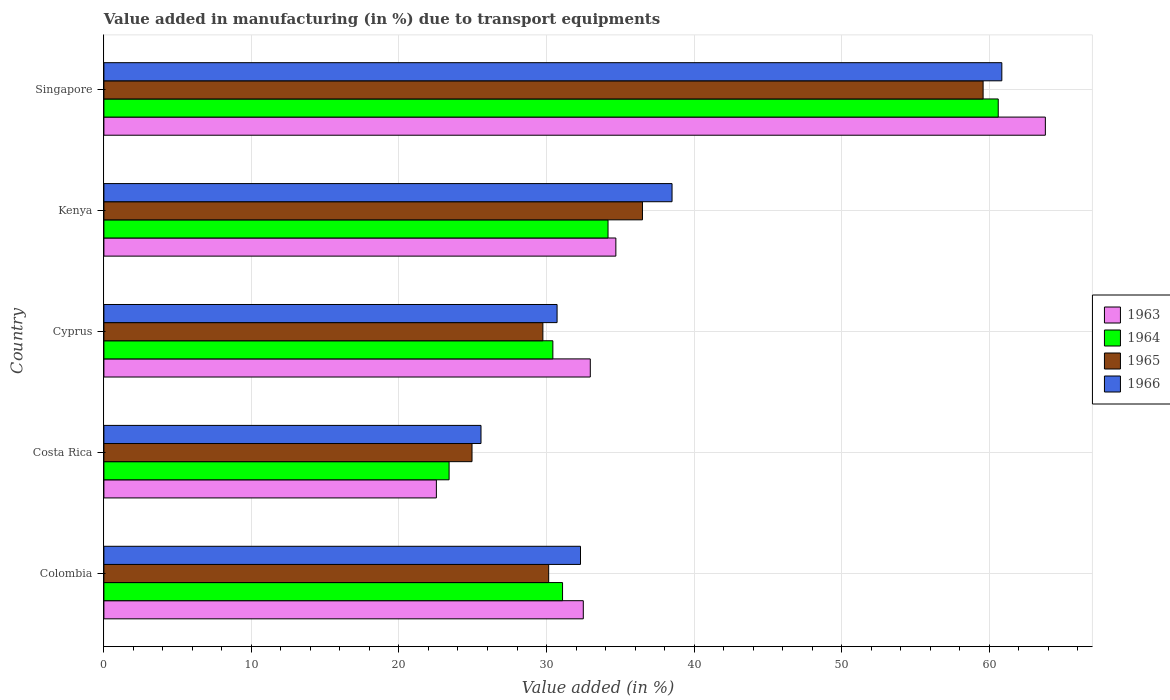How many different coloured bars are there?
Offer a terse response. 4. Are the number of bars per tick equal to the number of legend labels?
Your response must be concise. Yes. Are the number of bars on each tick of the Y-axis equal?
Offer a terse response. Yes. How many bars are there on the 2nd tick from the bottom?
Make the answer very short. 4. What is the label of the 4th group of bars from the top?
Make the answer very short. Costa Rica. In how many cases, is the number of bars for a given country not equal to the number of legend labels?
Your answer should be compact. 0. What is the percentage of value added in manufacturing due to transport equipments in 1963 in Cyprus?
Your response must be concise. 32.97. Across all countries, what is the maximum percentage of value added in manufacturing due to transport equipments in 1965?
Make the answer very short. 59.59. Across all countries, what is the minimum percentage of value added in manufacturing due to transport equipments in 1963?
Provide a short and direct response. 22.53. In which country was the percentage of value added in manufacturing due to transport equipments in 1965 maximum?
Provide a short and direct response. Singapore. What is the total percentage of value added in manufacturing due to transport equipments in 1964 in the graph?
Provide a succinct answer. 179.7. What is the difference between the percentage of value added in manufacturing due to transport equipments in 1963 in Colombia and that in Singapore?
Your response must be concise. -31.32. What is the difference between the percentage of value added in manufacturing due to transport equipments in 1963 in Cyprus and the percentage of value added in manufacturing due to transport equipments in 1964 in Costa Rica?
Your answer should be very brief. 9.57. What is the average percentage of value added in manufacturing due to transport equipments in 1965 per country?
Your answer should be compact. 36.19. What is the difference between the percentage of value added in manufacturing due to transport equipments in 1966 and percentage of value added in manufacturing due to transport equipments in 1965 in Costa Rica?
Offer a very short reply. 0.61. In how many countries, is the percentage of value added in manufacturing due to transport equipments in 1966 greater than 62 %?
Keep it short and to the point. 0. What is the ratio of the percentage of value added in manufacturing due to transport equipments in 1966 in Colombia to that in Kenya?
Your answer should be very brief. 0.84. What is the difference between the highest and the second highest percentage of value added in manufacturing due to transport equipments in 1966?
Keep it short and to the point. 22.35. What is the difference between the highest and the lowest percentage of value added in manufacturing due to transport equipments in 1965?
Make the answer very short. 34.64. Is the sum of the percentage of value added in manufacturing due to transport equipments in 1963 in Colombia and Costa Rica greater than the maximum percentage of value added in manufacturing due to transport equipments in 1964 across all countries?
Give a very brief answer. No. What does the 3rd bar from the top in Cyprus represents?
Give a very brief answer. 1964. What does the 1st bar from the bottom in Cyprus represents?
Your answer should be very brief. 1963. How many bars are there?
Your answer should be very brief. 20. What is the difference between two consecutive major ticks on the X-axis?
Give a very brief answer. 10. Does the graph contain any zero values?
Ensure brevity in your answer.  No. Does the graph contain grids?
Your response must be concise. Yes. What is the title of the graph?
Offer a very short reply. Value added in manufacturing (in %) due to transport equipments. Does "1979" appear as one of the legend labels in the graph?
Provide a short and direct response. No. What is the label or title of the X-axis?
Your answer should be very brief. Value added (in %). What is the label or title of the Y-axis?
Provide a succinct answer. Country. What is the Value added (in %) in 1963 in Colombia?
Keep it short and to the point. 32.49. What is the Value added (in %) of 1964 in Colombia?
Ensure brevity in your answer.  31.09. What is the Value added (in %) of 1965 in Colombia?
Ensure brevity in your answer.  30.15. What is the Value added (in %) of 1966 in Colombia?
Give a very brief answer. 32.3. What is the Value added (in %) of 1963 in Costa Rica?
Your answer should be very brief. 22.53. What is the Value added (in %) in 1964 in Costa Rica?
Keep it short and to the point. 23.4. What is the Value added (in %) in 1965 in Costa Rica?
Your answer should be very brief. 24.95. What is the Value added (in %) in 1966 in Costa Rica?
Your response must be concise. 25.56. What is the Value added (in %) in 1963 in Cyprus?
Keep it short and to the point. 32.97. What is the Value added (in %) of 1964 in Cyprus?
Ensure brevity in your answer.  30.43. What is the Value added (in %) of 1965 in Cyprus?
Provide a short and direct response. 29.75. What is the Value added (in %) of 1966 in Cyprus?
Your answer should be very brief. 30.72. What is the Value added (in %) of 1963 in Kenya?
Your answer should be compact. 34.7. What is the Value added (in %) of 1964 in Kenya?
Offer a very short reply. 34.17. What is the Value added (in %) of 1965 in Kenya?
Offer a terse response. 36.5. What is the Value added (in %) in 1966 in Kenya?
Offer a terse response. 38.51. What is the Value added (in %) in 1963 in Singapore?
Give a very brief answer. 63.81. What is the Value added (in %) in 1964 in Singapore?
Give a very brief answer. 60.62. What is the Value added (in %) of 1965 in Singapore?
Your response must be concise. 59.59. What is the Value added (in %) of 1966 in Singapore?
Provide a succinct answer. 60.86. Across all countries, what is the maximum Value added (in %) in 1963?
Give a very brief answer. 63.81. Across all countries, what is the maximum Value added (in %) of 1964?
Ensure brevity in your answer.  60.62. Across all countries, what is the maximum Value added (in %) in 1965?
Ensure brevity in your answer.  59.59. Across all countries, what is the maximum Value added (in %) of 1966?
Your response must be concise. 60.86. Across all countries, what is the minimum Value added (in %) in 1963?
Give a very brief answer. 22.53. Across all countries, what is the minimum Value added (in %) in 1964?
Your response must be concise. 23.4. Across all countries, what is the minimum Value added (in %) of 1965?
Ensure brevity in your answer.  24.95. Across all countries, what is the minimum Value added (in %) in 1966?
Ensure brevity in your answer.  25.56. What is the total Value added (in %) in 1963 in the graph?
Offer a very short reply. 186.5. What is the total Value added (in %) of 1964 in the graph?
Ensure brevity in your answer.  179.7. What is the total Value added (in %) in 1965 in the graph?
Give a very brief answer. 180.94. What is the total Value added (in %) of 1966 in the graph?
Make the answer very short. 187.95. What is the difference between the Value added (in %) in 1963 in Colombia and that in Costa Rica?
Your response must be concise. 9.96. What is the difference between the Value added (in %) of 1964 in Colombia and that in Costa Rica?
Ensure brevity in your answer.  7.69. What is the difference between the Value added (in %) in 1965 in Colombia and that in Costa Rica?
Give a very brief answer. 5.2. What is the difference between the Value added (in %) in 1966 in Colombia and that in Costa Rica?
Your answer should be very brief. 6.74. What is the difference between the Value added (in %) of 1963 in Colombia and that in Cyprus?
Make the answer very short. -0.47. What is the difference between the Value added (in %) of 1964 in Colombia and that in Cyprus?
Ensure brevity in your answer.  0.66. What is the difference between the Value added (in %) of 1965 in Colombia and that in Cyprus?
Your answer should be very brief. 0.39. What is the difference between the Value added (in %) of 1966 in Colombia and that in Cyprus?
Offer a terse response. 1.59. What is the difference between the Value added (in %) of 1963 in Colombia and that in Kenya?
Give a very brief answer. -2.21. What is the difference between the Value added (in %) in 1964 in Colombia and that in Kenya?
Your answer should be compact. -3.08. What is the difference between the Value added (in %) in 1965 in Colombia and that in Kenya?
Your response must be concise. -6.36. What is the difference between the Value added (in %) of 1966 in Colombia and that in Kenya?
Your response must be concise. -6.2. What is the difference between the Value added (in %) in 1963 in Colombia and that in Singapore?
Your answer should be compact. -31.32. What is the difference between the Value added (in %) of 1964 in Colombia and that in Singapore?
Make the answer very short. -29.53. What is the difference between the Value added (in %) in 1965 in Colombia and that in Singapore?
Give a very brief answer. -29.45. What is the difference between the Value added (in %) in 1966 in Colombia and that in Singapore?
Ensure brevity in your answer.  -28.56. What is the difference between the Value added (in %) of 1963 in Costa Rica and that in Cyprus?
Ensure brevity in your answer.  -10.43. What is the difference between the Value added (in %) of 1964 in Costa Rica and that in Cyprus?
Your answer should be very brief. -7.03. What is the difference between the Value added (in %) in 1965 in Costa Rica and that in Cyprus?
Your answer should be very brief. -4.8. What is the difference between the Value added (in %) of 1966 in Costa Rica and that in Cyprus?
Offer a terse response. -5.16. What is the difference between the Value added (in %) in 1963 in Costa Rica and that in Kenya?
Offer a very short reply. -12.17. What is the difference between the Value added (in %) in 1964 in Costa Rica and that in Kenya?
Your answer should be very brief. -10.77. What is the difference between the Value added (in %) in 1965 in Costa Rica and that in Kenya?
Offer a very short reply. -11.55. What is the difference between the Value added (in %) of 1966 in Costa Rica and that in Kenya?
Ensure brevity in your answer.  -12.95. What is the difference between the Value added (in %) of 1963 in Costa Rica and that in Singapore?
Make the answer very short. -41.28. What is the difference between the Value added (in %) in 1964 in Costa Rica and that in Singapore?
Give a very brief answer. -37.22. What is the difference between the Value added (in %) in 1965 in Costa Rica and that in Singapore?
Offer a terse response. -34.64. What is the difference between the Value added (in %) in 1966 in Costa Rica and that in Singapore?
Make the answer very short. -35.3. What is the difference between the Value added (in %) in 1963 in Cyprus and that in Kenya?
Your response must be concise. -1.73. What is the difference between the Value added (in %) of 1964 in Cyprus and that in Kenya?
Give a very brief answer. -3.74. What is the difference between the Value added (in %) in 1965 in Cyprus and that in Kenya?
Offer a very short reply. -6.75. What is the difference between the Value added (in %) in 1966 in Cyprus and that in Kenya?
Ensure brevity in your answer.  -7.79. What is the difference between the Value added (in %) in 1963 in Cyprus and that in Singapore?
Offer a very short reply. -30.84. What is the difference between the Value added (in %) of 1964 in Cyprus and that in Singapore?
Give a very brief answer. -30.19. What is the difference between the Value added (in %) in 1965 in Cyprus and that in Singapore?
Provide a succinct answer. -29.84. What is the difference between the Value added (in %) of 1966 in Cyprus and that in Singapore?
Your response must be concise. -30.14. What is the difference between the Value added (in %) of 1963 in Kenya and that in Singapore?
Make the answer very short. -29.11. What is the difference between the Value added (in %) in 1964 in Kenya and that in Singapore?
Offer a terse response. -26.45. What is the difference between the Value added (in %) in 1965 in Kenya and that in Singapore?
Offer a terse response. -23.09. What is the difference between the Value added (in %) in 1966 in Kenya and that in Singapore?
Make the answer very short. -22.35. What is the difference between the Value added (in %) in 1963 in Colombia and the Value added (in %) in 1964 in Costa Rica?
Make the answer very short. 9.1. What is the difference between the Value added (in %) of 1963 in Colombia and the Value added (in %) of 1965 in Costa Rica?
Your answer should be very brief. 7.54. What is the difference between the Value added (in %) in 1963 in Colombia and the Value added (in %) in 1966 in Costa Rica?
Make the answer very short. 6.93. What is the difference between the Value added (in %) in 1964 in Colombia and the Value added (in %) in 1965 in Costa Rica?
Ensure brevity in your answer.  6.14. What is the difference between the Value added (in %) in 1964 in Colombia and the Value added (in %) in 1966 in Costa Rica?
Your answer should be compact. 5.53. What is the difference between the Value added (in %) in 1965 in Colombia and the Value added (in %) in 1966 in Costa Rica?
Keep it short and to the point. 4.59. What is the difference between the Value added (in %) of 1963 in Colombia and the Value added (in %) of 1964 in Cyprus?
Provide a succinct answer. 2.06. What is the difference between the Value added (in %) in 1963 in Colombia and the Value added (in %) in 1965 in Cyprus?
Provide a succinct answer. 2.74. What is the difference between the Value added (in %) of 1963 in Colombia and the Value added (in %) of 1966 in Cyprus?
Give a very brief answer. 1.78. What is the difference between the Value added (in %) of 1964 in Colombia and the Value added (in %) of 1965 in Cyprus?
Your response must be concise. 1.33. What is the difference between the Value added (in %) in 1964 in Colombia and the Value added (in %) in 1966 in Cyprus?
Make the answer very short. 0.37. What is the difference between the Value added (in %) in 1965 in Colombia and the Value added (in %) in 1966 in Cyprus?
Offer a terse response. -0.57. What is the difference between the Value added (in %) in 1963 in Colombia and the Value added (in %) in 1964 in Kenya?
Provide a short and direct response. -1.68. What is the difference between the Value added (in %) in 1963 in Colombia and the Value added (in %) in 1965 in Kenya?
Offer a very short reply. -4.01. What is the difference between the Value added (in %) of 1963 in Colombia and the Value added (in %) of 1966 in Kenya?
Your answer should be compact. -6.01. What is the difference between the Value added (in %) in 1964 in Colombia and the Value added (in %) in 1965 in Kenya?
Offer a very short reply. -5.42. What is the difference between the Value added (in %) of 1964 in Colombia and the Value added (in %) of 1966 in Kenya?
Your answer should be very brief. -7.42. What is the difference between the Value added (in %) in 1965 in Colombia and the Value added (in %) in 1966 in Kenya?
Your answer should be compact. -8.36. What is the difference between the Value added (in %) in 1963 in Colombia and the Value added (in %) in 1964 in Singapore?
Provide a short and direct response. -28.12. What is the difference between the Value added (in %) in 1963 in Colombia and the Value added (in %) in 1965 in Singapore?
Provide a succinct answer. -27.1. What is the difference between the Value added (in %) of 1963 in Colombia and the Value added (in %) of 1966 in Singapore?
Ensure brevity in your answer.  -28.37. What is the difference between the Value added (in %) of 1964 in Colombia and the Value added (in %) of 1965 in Singapore?
Provide a succinct answer. -28.51. What is the difference between the Value added (in %) in 1964 in Colombia and the Value added (in %) in 1966 in Singapore?
Your response must be concise. -29.77. What is the difference between the Value added (in %) of 1965 in Colombia and the Value added (in %) of 1966 in Singapore?
Provide a short and direct response. -30.71. What is the difference between the Value added (in %) in 1963 in Costa Rica and the Value added (in %) in 1964 in Cyprus?
Your answer should be very brief. -7.9. What is the difference between the Value added (in %) in 1963 in Costa Rica and the Value added (in %) in 1965 in Cyprus?
Your answer should be compact. -7.22. What is the difference between the Value added (in %) in 1963 in Costa Rica and the Value added (in %) in 1966 in Cyprus?
Give a very brief answer. -8.18. What is the difference between the Value added (in %) of 1964 in Costa Rica and the Value added (in %) of 1965 in Cyprus?
Give a very brief answer. -6.36. What is the difference between the Value added (in %) of 1964 in Costa Rica and the Value added (in %) of 1966 in Cyprus?
Your answer should be very brief. -7.32. What is the difference between the Value added (in %) in 1965 in Costa Rica and the Value added (in %) in 1966 in Cyprus?
Offer a very short reply. -5.77. What is the difference between the Value added (in %) of 1963 in Costa Rica and the Value added (in %) of 1964 in Kenya?
Offer a terse response. -11.64. What is the difference between the Value added (in %) in 1963 in Costa Rica and the Value added (in %) in 1965 in Kenya?
Provide a short and direct response. -13.97. What is the difference between the Value added (in %) of 1963 in Costa Rica and the Value added (in %) of 1966 in Kenya?
Your answer should be very brief. -15.97. What is the difference between the Value added (in %) in 1964 in Costa Rica and the Value added (in %) in 1965 in Kenya?
Offer a very short reply. -13.11. What is the difference between the Value added (in %) of 1964 in Costa Rica and the Value added (in %) of 1966 in Kenya?
Your answer should be very brief. -15.11. What is the difference between the Value added (in %) in 1965 in Costa Rica and the Value added (in %) in 1966 in Kenya?
Give a very brief answer. -13.56. What is the difference between the Value added (in %) in 1963 in Costa Rica and the Value added (in %) in 1964 in Singapore?
Ensure brevity in your answer.  -38.08. What is the difference between the Value added (in %) in 1963 in Costa Rica and the Value added (in %) in 1965 in Singapore?
Offer a terse response. -37.06. What is the difference between the Value added (in %) in 1963 in Costa Rica and the Value added (in %) in 1966 in Singapore?
Provide a short and direct response. -38.33. What is the difference between the Value added (in %) of 1964 in Costa Rica and the Value added (in %) of 1965 in Singapore?
Provide a short and direct response. -36.19. What is the difference between the Value added (in %) in 1964 in Costa Rica and the Value added (in %) in 1966 in Singapore?
Your answer should be very brief. -37.46. What is the difference between the Value added (in %) in 1965 in Costa Rica and the Value added (in %) in 1966 in Singapore?
Offer a terse response. -35.91. What is the difference between the Value added (in %) in 1963 in Cyprus and the Value added (in %) in 1964 in Kenya?
Ensure brevity in your answer.  -1.2. What is the difference between the Value added (in %) of 1963 in Cyprus and the Value added (in %) of 1965 in Kenya?
Make the answer very short. -3.54. What is the difference between the Value added (in %) of 1963 in Cyprus and the Value added (in %) of 1966 in Kenya?
Offer a terse response. -5.54. What is the difference between the Value added (in %) of 1964 in Cyprus and the Value added (in %) of 1965 in Kenya?
Your response must be concise. -6.07. What is the difference between the Value added (in %) in 1964 in Cyprus and the Value added (in %) in 1966 in Kenya?
Offer a terse response. -8.08. What is the difference between the Value added (in %) in 1965 in Cyprus and the Value added (in %) in 1966 in Kenya?
Ensure brevity in your answer.  -8.75. What is the difference between the Value added (in %) of 1963 in Cyprus and the Value added (in %) of 1964 in Singapore?
Offer a very short reply. -27.65. What is the difference between the Value added (in %) of 1963 in Cyprus and the Value added (in %) of 1965 in Singapore?
Your answer should be very brief. -26.62. What is the difference between the Value added (in %) of 1963 in Cyprus and the Value added (in %) of 1966 in Singapore?
Your response must be concise. -27.89. What is the difference between the Value added (in %) in 1964 in Cyprus and the Value added (in %) in 1965 in Singapore?
Give a very brief answer. -29.16. What is the difference between the Value added (in %) in 1964 in Cyprus and the Value added (in %) in 1966 in Singapore?
Offer a very short reply. -30.43. What is the difference between the Value added (in %) of 1965 in Cyprus and the Value added (in %) of 1966 in Singapore?
Your answer should be compact. -31.11. What is the difference between the Value added (in %) in 1963 in Kenya and the Value added (in %) in 1964 in Singapore?
Your response must be concise. -25.92. What is the difference between the Value added (in %) in 1963 in Kenya and the Value added (in %) in 1965 in Singapore?
Make the answer very short. -24.89. What is the difference between the Value added (in %) in 1963 in Kenya and the Value added (in %) in 1966 in Singapore?
Your response must be concise. -26.16. What is the difference between the Value added (in %) in 1964 in Kenya and the Value added (in %) in 1965 in Singapore?
Your response must be concise. -25.42. What is the difference between the Value added (in %) in 1964 in Kenya and the Value added (in %) in 1966 in Singapore?
Give a very brief answer. -26.69. What is the difference between the Value added (in %) in 1965 in Kenya and the Value added (in %) in 1966 in Singapore?
Make the answer very short. -24.36. What is the average Value added (in %) of 1963 per country?
Make the answer very short. 37.3. What is the average Value added (in %) of 1964 per country?
Provide a succinct answer. 35.94. What is the average Value added (in %) in 1965 per country?
Offer a very short reply. 36.19. What is the average Value added (in %) of 1966 per country?
Offer a very short reply. 37.59. What is the difference between the Value added (in %) in 1963 and Value added (in %) in 1964 in Colombia?
Give a very brief answer. 1.41. What is the difference between the Value added (in %) of 1963 and Value added (in %) of 1965 in Colombia?
Provide a short and direct response. 2.35. What is the difference between the Value added (in %) in 1963 and Value added (in %) in 1966 in Colombia?
Make the answer very short. 0.19. What is the difference between the Value added (in %) of 1964 and Value added (in %) of 1965 in Colombia?
Ensure brevity in your answer.  0.94. What is the difference between the Value added (in %) of 1964 and Value added (in %) of 1966 in Colombia?
Make the answer very short. -1.22. What is the difference between the Value added (in %) in 1965 and Value added (in %) in 1966 in Colombia?
Offer a very short reply. -2.16. What is the difference between the Value added (in %) in 1963 and Value added (in %) in 1964 in Costa Rica?
Give a very brief answer. -0.86. What is the difference between the Value added (in %) of 1963 and Value added (in %) of 1965 in Costa Rica?
Ensure brevity in your answer.  -2.42. What is the difference between the Value added (in %) in 1963 and Value added (in %) in 1966 in Costa Rica?
Provide a short and direct response. -3.03. What is the difference between the Value added (in %) in 1964 and Value added (in %) in 1965 in Costa Rica?
Your answer should be compact. -1.55. What is the difference between the Value added (in %) of 1964 and Value added (in %) of 1966 in Costa Rica?
Give a very brief answer. -2.16. What is the difference between the Value added (in %) in 1965 and Value added (in %) in 1966 in Costa Rica?
Your answer should be compact. -0.61. What is the difference between the Value added (in %) of 1963 and Value added (in %) of 1964 in Cyprus?
Offer a very short reply. 2.54. What is the difference between the Value added (in %) in 1963 and Value added (in %) in 1965 in Cyprus?
Make the answer very short. 3.21. What is the difference between the Value added (in %) in 1963 and Value added (in %) in 1966 in Cyprus?
Give a very brief answer. 2.25. What is the difference between the Value added (in %) in 1964 and Value added (in %) in 1965 in Cyprus?
Give a very brief answer. 0.68. What is the difference between the Value added (in %) of 1964 and Value added (in %) of 1966 in Cyprus?
Provide a short and direct response. -0.29. What is the difference between the Value added (in %) of 1965 and Value added (in %) of 1966 in Cyprus?
Provide a succinct answer. -0.96. What is the difference between the Value added (in %) in 1963 and Value added (in %) in 1964 in Kenya?
Your response must be concise. 0.53. What is the difference between the Value added (in %) in 1963 and Value added (in %) in 1965 in Kenya?
Make the answer very short. -1.8. What is the difference between the Value added (in %) in 1963 and Value added (in %) in 1966 in Kenya?
Your answer should be very brief. -3.81. What is the difference between the Value added (in %) of 1964 and Value added (in %) of 1965 in Kenya?
Keep it short and to the point. -2.33. What is the difference between the Value added (in %) of 1964 and Value added (in %) of 1966 in Kenya?
Offer a very short reply. -4.34. What is the difference between the Value added (in %) of 1965 and Value added (in %) of 1966 in Kenya?
Provide a short and direct response. -2. What is the difference between the Value added (in %) of 1963 and Value added (in %) of 1964 in Singapore?
Make the answer very short. 3.19. What is the difference between the Value added (in %) of 1963 and Value added (in %) of 1965 in Singapore?
Give a very brief answer. 4.22. What is the difference between the Value added (in %) in 1963 and Value added (in %) in 1966 in Singapore?
Your response must be concise. 2.95. What is the difference between the Value added (in %) of 1964 and Value added (in %) of 1965 in Singapore?
Provide a succinct answer. 1.03. What is the difference between the Value added (in %) in 1964 and Value added (in %) in 1966 in Singapore?
Give a very brief answer. -0.24. What is the difference between the Value added (in %) in 1965 and Value added (in %) in 1966 in Singapore?
Provide a succinct answer. -1.27. What is the ratio of the Value added (in %) of 1963 in Colombia to that in Costa Rica?
Your answer should be compact. 1.44. What is the ratio of the Value added (in %) of 1964 in Colombia to that in Costa Rica?
Ensure brevity in your answer.  1.33. What is the ratio of the Value added (in %) of 1965 in Colombia to that in Costa Rica?
Your response must be concise. 1.21. What is the ratio of the Value added (in %) of 1966 in Colombia to that in Costa Rica?
Give a very brief answer. 1.26. What is the ratio of the Value added (in %) in 1963 in Colombia to that in Cyprus?
Your answer should be very brief. 0.99. What is the ratio of the Value added (in %) of 1964 in Colombia to that in Cyprus?
Offer a very short reply. 1.02. What is the ratio of the Value added (in %) in 1965 in Colombia to that in Cyprus?
Offer a very short reply. 1.01. What is the ratio of the Value added (in %) in 1966 in Colombia to that in Cyprus?
Keep it short and to the point. 1.05. What is the ratio of the Value added (in %) in 1963 in Colombia to that in Kenya?
Your answer should be very brief. 0.94. What is the ratio of the Value added (in %) in 1964 in Colombia to that in Kenya?
Offer a very short reply. 0.91. What is the ratio of the Value added (in %) of 1965 in Colombia to that in Kenya?
Your answer should be compact. 0.83. What is the ratio of the Value added (in %) of 1966 in Colombia to that in Kenya?
Ensure brevity in your answer.  0.84. What is the ratio of the Value added (in %) of 1963 in Colombia to that in Singapore?
Your answer should be compact. 0.51. What is the ratio of the Value added (in %) in 1964 in Colombia to that in Singapore?
Your answer should be very brief. 0.51. What is the ratio of the Value added (in %) of 1965 in Colombia to that in Singapore?
Keep it short and to the point. 0.51. What is the ratio of the Value added (in %) in 1966 in Colombia to that in Singapore?
Your answer should be compact. 0.53. What is the ratio of the Value added (in %) in 1963 in Costa Rica to that in Cyprus?
Ensure brevity in your answer.  0.68. What is the ratio of the Value added (in %) of 1964 in Costa Rica to that in Cyprus?
Provide a short and direct response. 0.77. What is the ratio of the Value added (in %) in 1965 in Costa Rica to that in Cyprus?
Your answer should be compact. 0.84. What is the ratio of the Value added (in %) in 1966 in Costa Rica to that in Cyprus?
Your answer should be compact. 0.83. What is the ratio of the Value added (in %) in 1963 in Costa Rica to that in Kenya?
Your answer should be very brief. 0.65. What is the ratio of the Value added (in %) in 1964 in Costa Rica to that in Kenya?
Offer a terse response. 0.68. What is the ratio of the Value added (in %) of 1965 in Costa Rica to that in Kenya?
Offer a terse response. 0.68. What is the ratio of the Value added (in %) in 1966 in Costa Rica to that in Kenya?
Offer a terse response. 0.66. What is the ratio of the Value added (in %) in 1963 in Costa Rica to that in Singapore?
Your answer should be very brief. 0.35. What is the ratio of the Value added (in %) in 1964 in Costa Rica to that in Singapore?
Give a very brief answer. 0.39. What is the ratio of the Value added (in %) of 1965 in Costa Rica to that in Singapore?
Your response must be concise. 0.42. What is the ratio of the Value added (in %) in 1966 in Costa Rica to that in Singapore?
Give a very brief answer. 0.42. What is the ratio of the Value added (in %) of 1963 in Cyprus to that in Kenya?
Give a very brief answer. 0.95. What is the ratio of the Value added (in %) of 1964 in Cyprus to that in Kenya?
Your answer should be very brief. 0.89. What is the ratio of the Value added (in %) of 1965 in Cyprus to that in Kenya?
Make the answer very short. 0.82. What is the ratio of the Value added (in %) of 1966 in Cyprus to that in Kenya?
Your answer should be very brief. 0.8. What is the ratio of the Value added (in %) of 1963 in Cyprus to that in Singapore?
Provide a short and direct response. 0.52. What is the ratio of the Value added (in %) in 1964 in Cyprus to that in Singapore?
Offer a very short reply. 0.5. What is the ratio of the Value added (in %) of 1965 in Cyprus to that in Singapore?
Your answer should be very brief. 0.5. What is the ratio of the Value added (in %) of 1966 in Cyprus to that in Singapore?
Your answer should be very brief. 0.5. What is the ratio of the Value added (in %) in 1963 in Kenya to that in Singapore?
Your answer should be compact. 0.54. What is the ratio of the Value added (in %) of 1964 in Kenya to that in Singapore?
Ensure brevity in your answer.  0.56. What is the ratio of the Value added (in %) of 1965 in Kenya to that in Singapore?
Your answer should be very brief. 0.61. What is the ratio of the Value added (in %) of 1966 in Kenya to that in Singapore?
Give a very brief answer. 0.63. What is the difference between the highest and the second highest Value added (in %) in 1963?
Your response must be concise. 29.11. What is the difference between the highest and the second highest Value added (in %) in 1964?
Provide a short and direct response. 26.45. What is the difference between the highest and the second highest Value added (in %) of 1965?
Make the answer very short. 23.09. What is the difference between the highest and the second highest Value added (in %) in 1966?
Keep it short and to the point. 22.35. What is the difference between the highest and the lowest Value added (in %) of 1963?
Your answer should be compact. 41.28. What is the difference between the highest and the lowest Value added (in %) in 1964?
Ensure brevity in your answer.  37.22. What is the difference between the highest and the lowest Value added (in %) in 1965?
Ensure brevity in your answer.  34.64. What is the difference between the highest and the lowest Value added (in %) of 1966?
Provide a short and direct response. 35.3. 